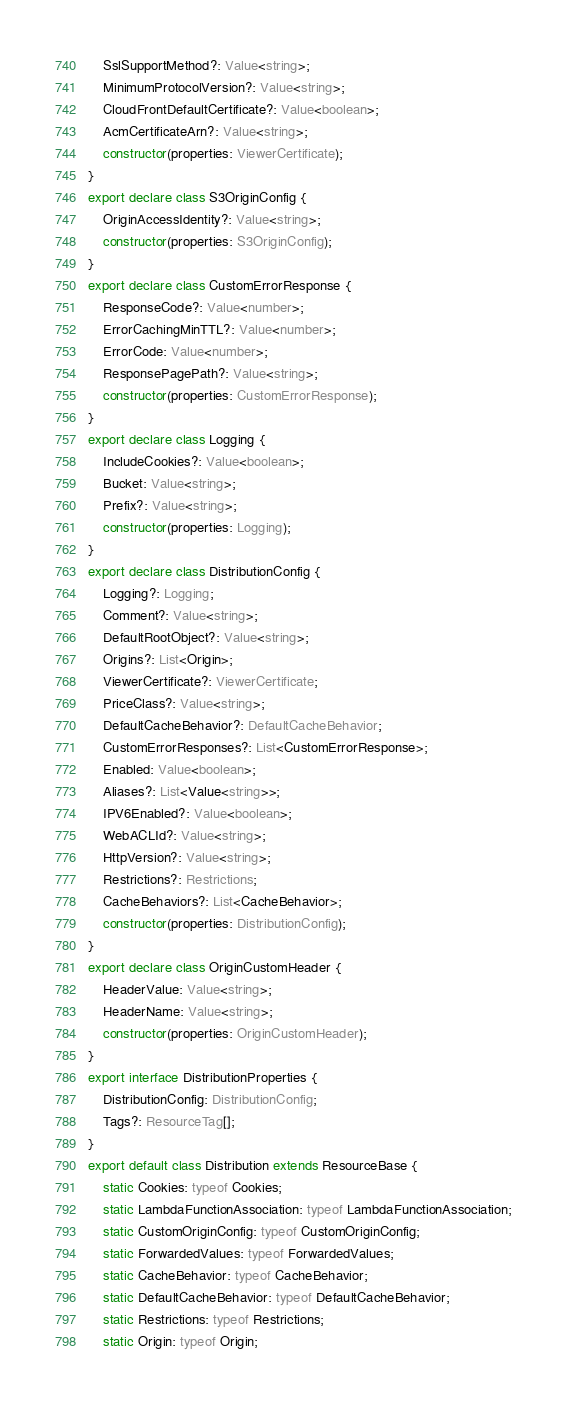<code> <loc_0><loc_0><loc_500><loc_500><_TypeScript_>    SslSupportMethod?: Value<string>;
    MinimumProtocolVersion?: Value<string>;
    CloudFrontDefaultCertificate?: Value<boolean>;
    AcmCertificateArn?: Value<string>;
    constructor(properties: ViewerCertificate);
}
export declare class S3OriginConfig {
    OriginAccessIdentity?: Value<string>;
    constructor(properties: S3OriginConfig);
}
export declare class CustomErrorResponse {
    ResponseCode?: Value<number>;
    ErrorCachingMinTTL?: Value<number>;
    ErrorCode: Value<number>;
    ResponsePagePath?: Value<string>;
    constructor(properties: CustomErrorResponse);
}
export declare class Logging {
    IncludeCookies?: Value<boolean>;
    Bucket: Value<string>;
    Prefix?: Value<string>;
    constructor(properties: Logging);
}
export declare class DistributionConfig {
    Logging?: Logging;
    Comment?: Value<string>;
    DefaultRootObject?: Value<string>;
    Origins?: List<Origin>;
    ViewerCertificate?: ViewerCertificate;
    PriceClass?: Value<string>;
    DefaultCacheBehavior?: DefaultCacheBehavior;
    CustomErrorResponses?: List<CustomErrorResponse>;
    Enabled: Value<boolean>;
    Aliases?: List<Value<string>>;
    IPV6Enabled?: Value<boolean>;
    WebACLId?: Value<string>;
    HttpVersion?: Value<string>;
    Restrictions?: Restrictions;
    CacheBehaviors?: List<CacheBehavior>;
    constructor(properties: DistributionConfig);
}
export declare class OriginCustomHeader {
    HeaderValue: Value<string>;
    HeaderName: Value<string>;
    constructor(properties: OriginCustomHeader);
}
export interface DistributionProperties {
    DistributionConfig: DistributionConfig;
    Tags?: ResourceTag[];
}
export default class Distribution extends ResourceBase {
    static Cookies: typeof Cookies;
    static LambdaFunctionAssociation: typeof LambdaFunctionAssociation;
    static CustomOriginConfig: typeof CustomOriginConfig;
    static ForwardedValues: typeof ForwardedValues;
    static CacheBehavior: typeof CacheBehavior;
    static DefaultCacheBehavior: typeof DefaultCacheBehavior;
    static Restrictions: typeof Restrictions;
    static Origin: typeof Origin;</code> 